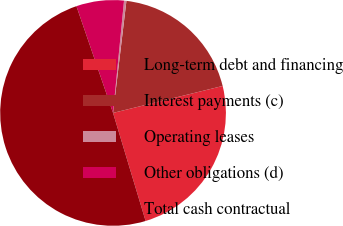Convert chart. <chart><loc_0><loc_0><loc_500><loc_500><pie_chart><fcel>Long-term debt and financing<fcel>Interest payments (c)<fcel>Operating leases<fcel>Other obligations (d)<fcel>Total cash contractual<nl><fcel>24.18%<fcel>19.27%<fcel>0.34%<fcel>6.81%<fcel>49.4%<nl></chart> 